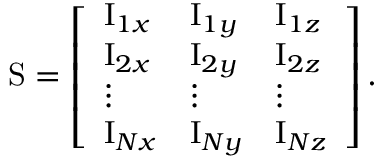<formula> <loc_0><loc_0><loc_500><loc_500>S = \left [ \begin{array} { l l l } { I _ { 1 x } } & { I _ { 1 y } } & { I _ { 1 z } } \\ { I _ { 2 x } } & { I _ { 2 y } } & { I _ { 2 z } } \\ { \vdots } & { \vdots } & { \vdots } \\ { I _ { N x } } & { I _ { N y } } & { I _ { N z } } \end{array} \right ] .</formula> 